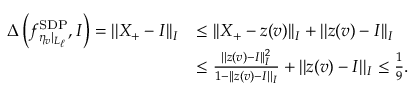<formula> <loc_0><loc_0><loc_500><loc_500>\begin{array} { r l } { \Delta \left ( f _ { \eta _ { v } | _ { L _ { \ell } } } ^ { S D P } , I \right ) = | | X _ { + } - I | | _ { I } } & { \leq | | X _ { + } - z ( v ) | | _ { I } + | | z ( v ) - I | | _ { I } } \\ & { \leq \frac { | | z ( v ) - I | | _ { I } ^ { 2 } } { 1 - | | z ( v ) - I | | _ { I } } + | | z ( v ) - I | | _ { I } \leq \frac { 1 } { 9 } . } \end{array}</formula> 